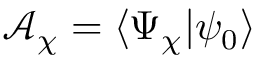Convert formula to latex. <formula><loc_0><loc_0><loc_500><loc_500>\mathcal { A } _ { \chi } = \langle \Psi _ { \chi } | \psi _ { 0 } \rangle</formula> 